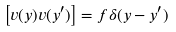<formula> <loc_0><loc_0><loc_500><loc_500>\left [ v ( { y } ) v ( { y } ^ { \prime } ) \right ] = f \delta ( { y } - { y } ^ { \prime } )</formula> 